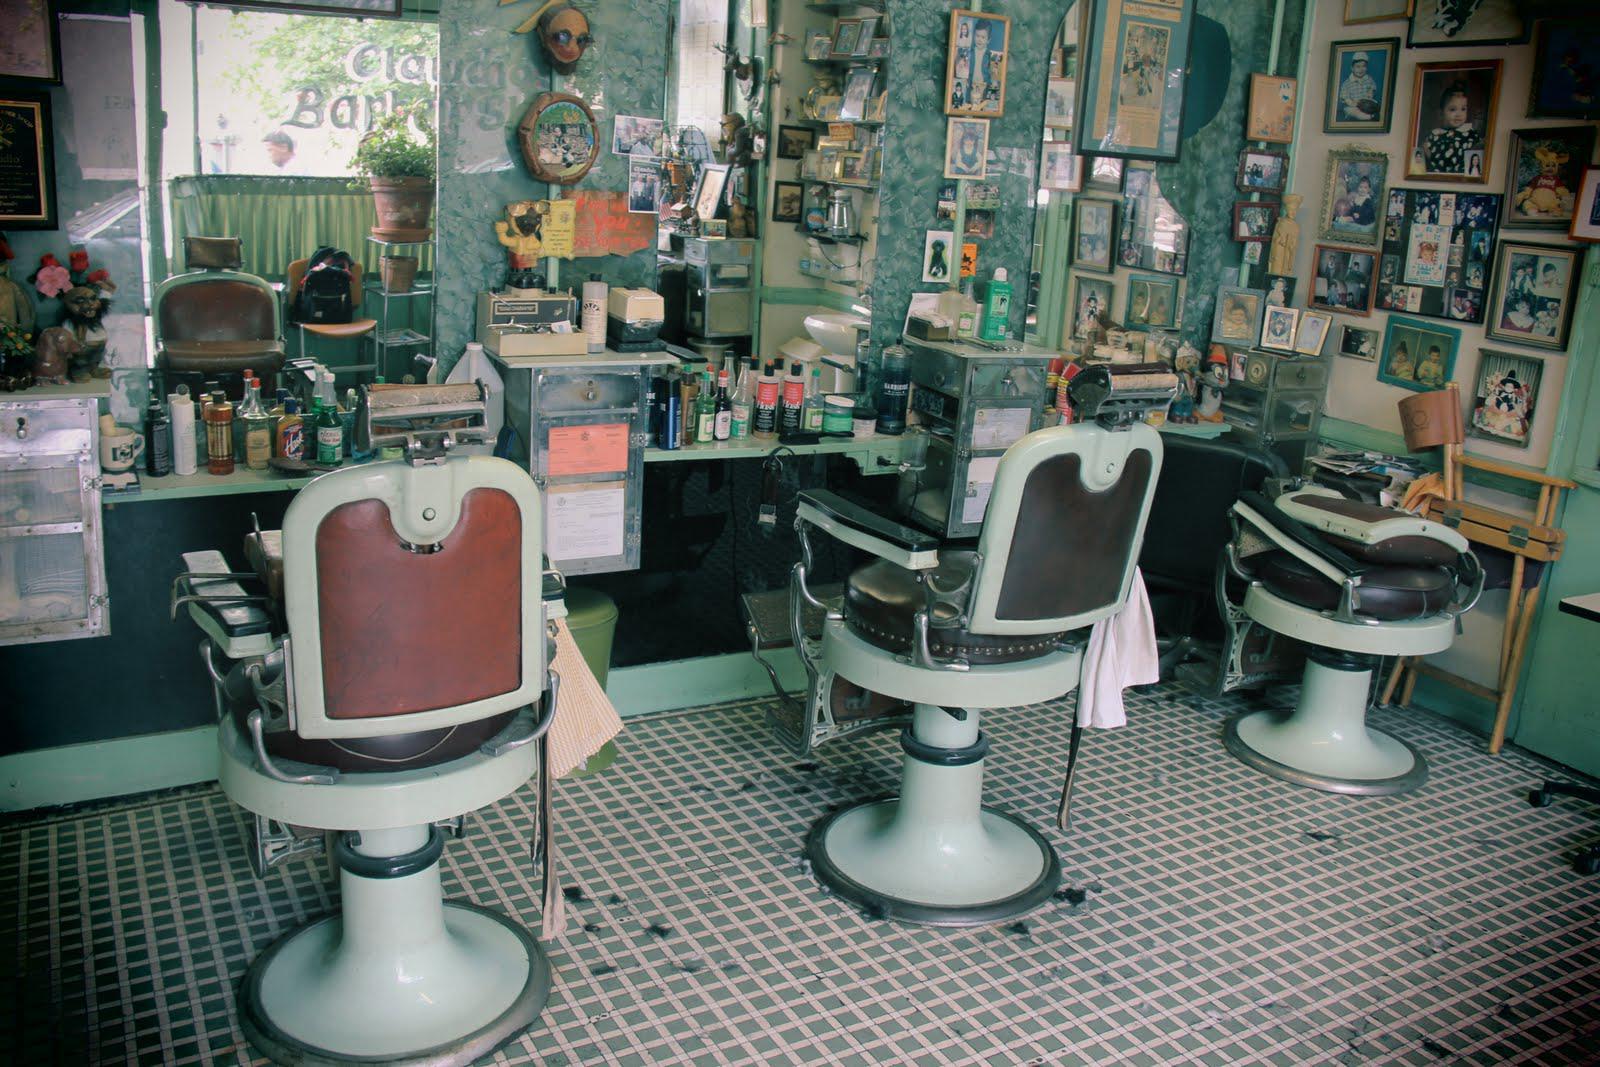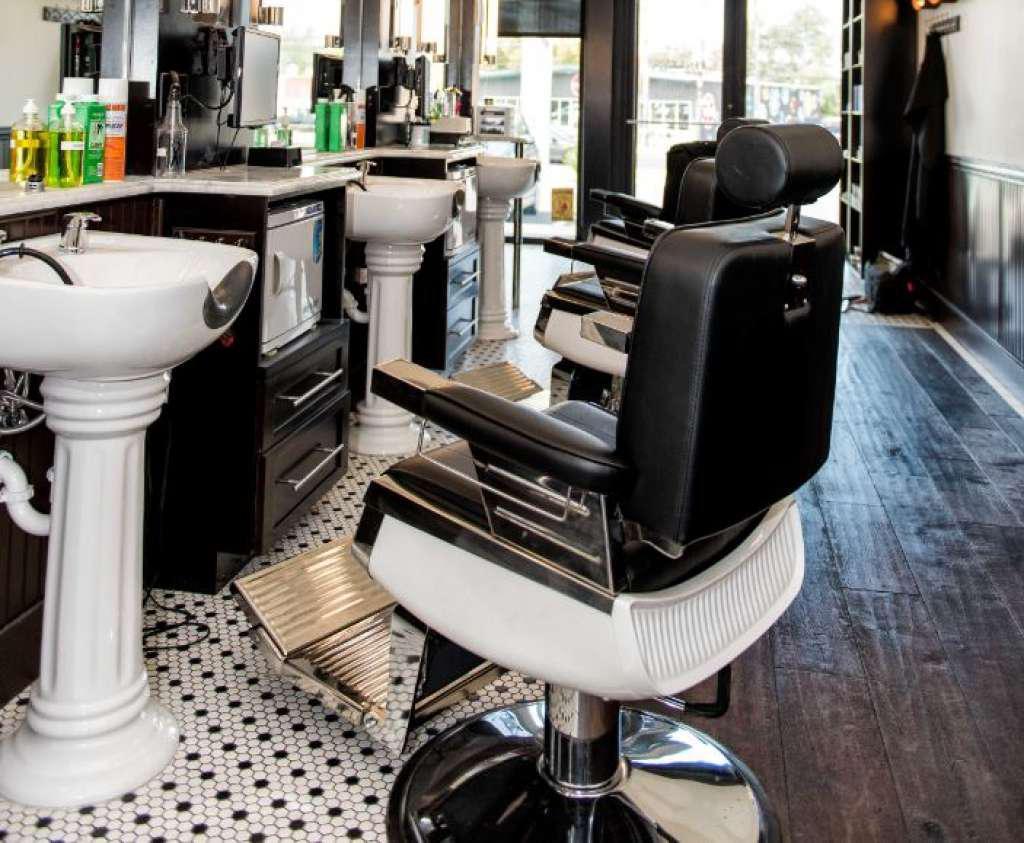The first image is the image on the left, the second image is the image on the right. For the images displayed, is the sentence "There are more than eleven frames on the wall in one of the images." factually correct? Answer yes or no. Yes. 